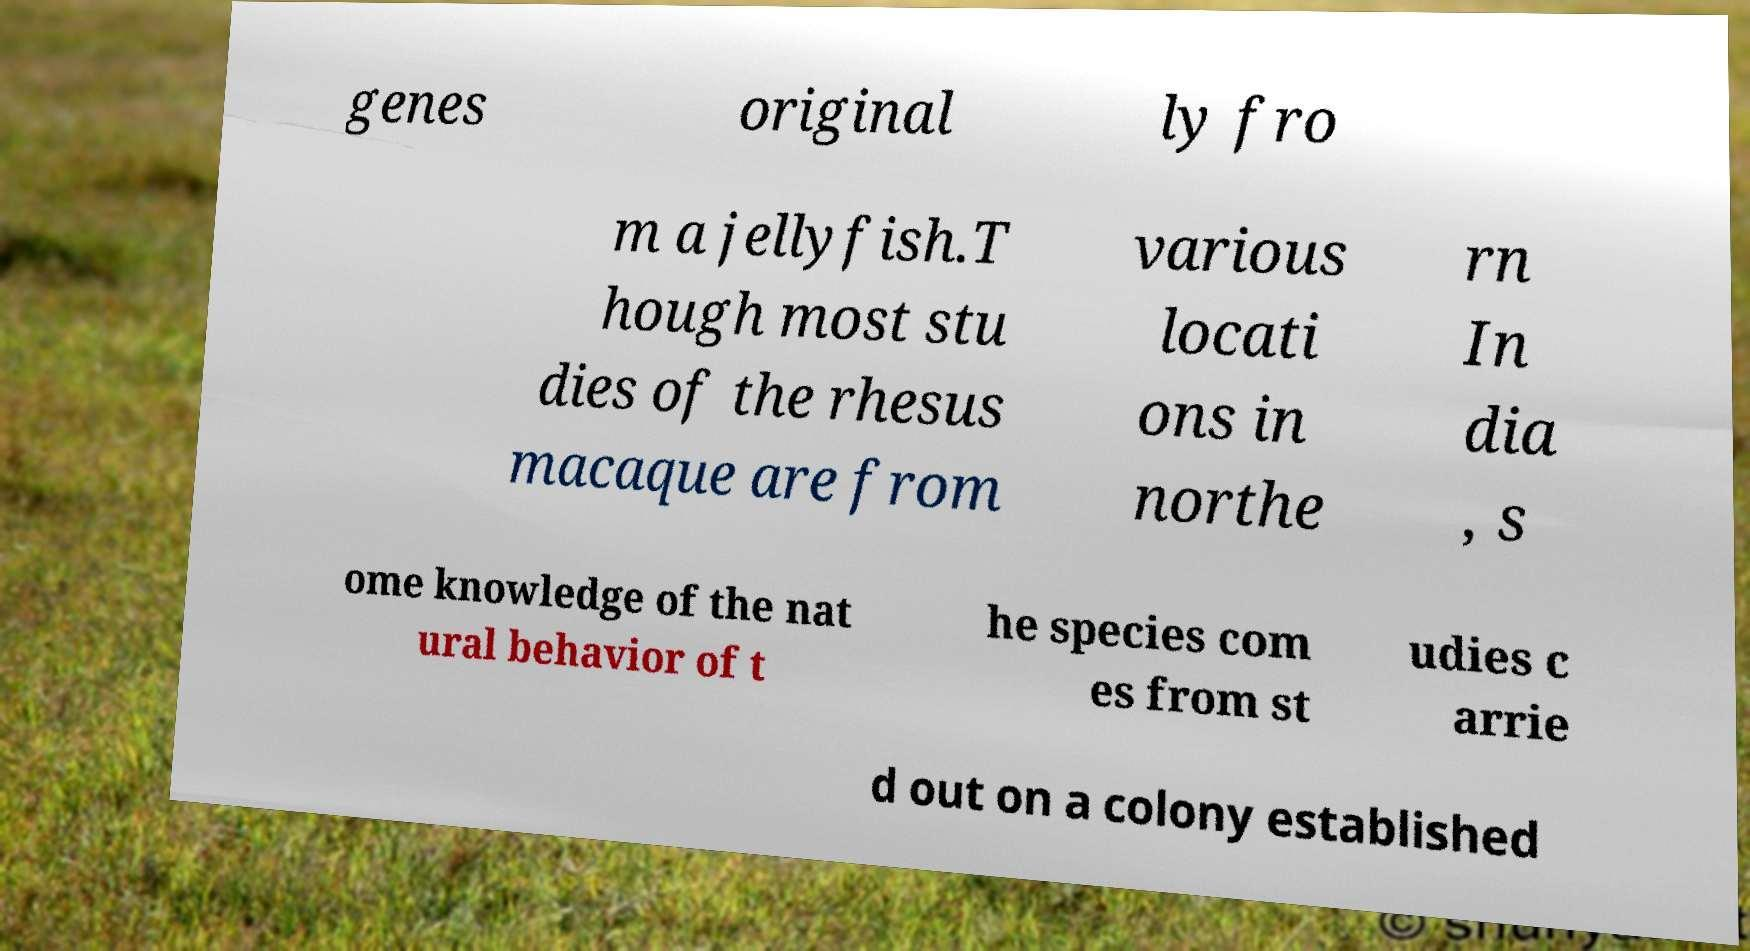I need the written content from this picture converted into text. Can you do that? genes original ly fro m a jellyfish.T hough most stu dies of the rhesus macaque are from various locati ons in northe rn In dia , s ome knowledge of the nat ural behavior of t he species com es from st udies c arrie d out on a colony established 